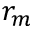<formula> <loc_0><loc_0><loc_500><loc_500>r _ { m }</formula> 